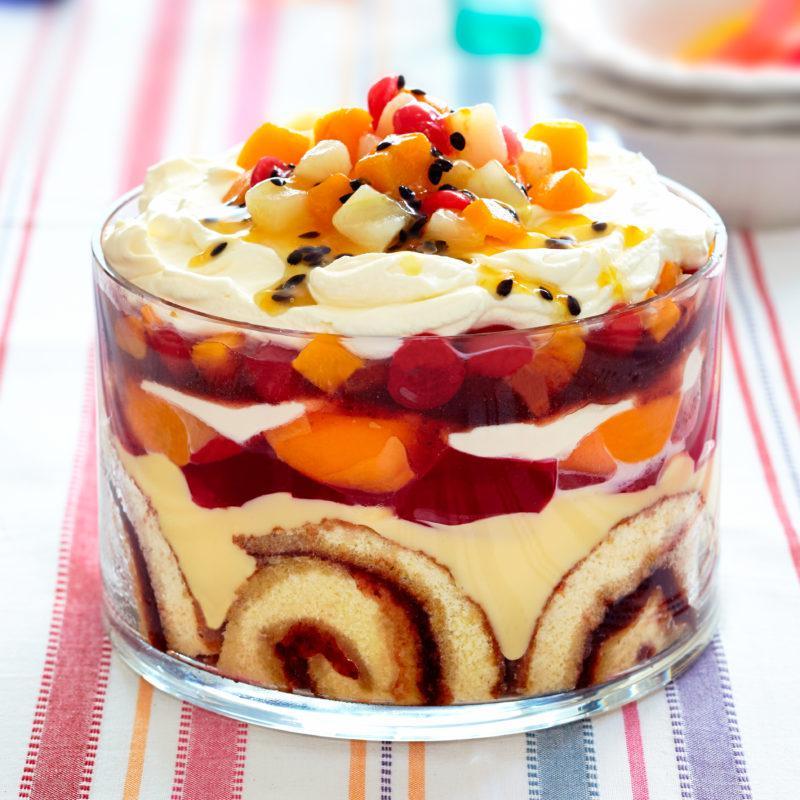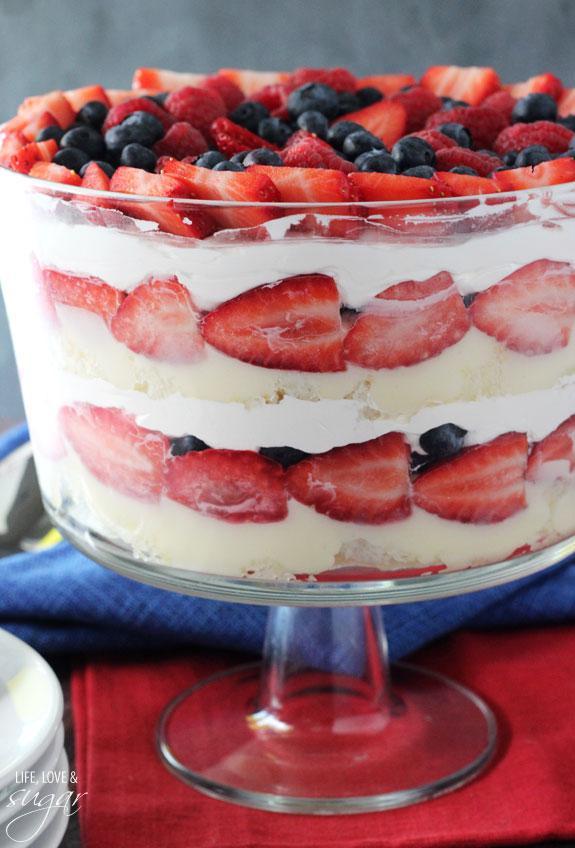The first image is the image on the left, the second image is the image on the right. Assess this claim about the two images: "Two large fancy layered desserts are made with sliced strawberries.". Correct or not? Answer yes or no. No. The first image is the image on the left, the second image is the image on the right. Given the left and right images, does the statement "The dessert is sitting on a folded red and white cloth in one image." hold true? Answer yes or no. No. 